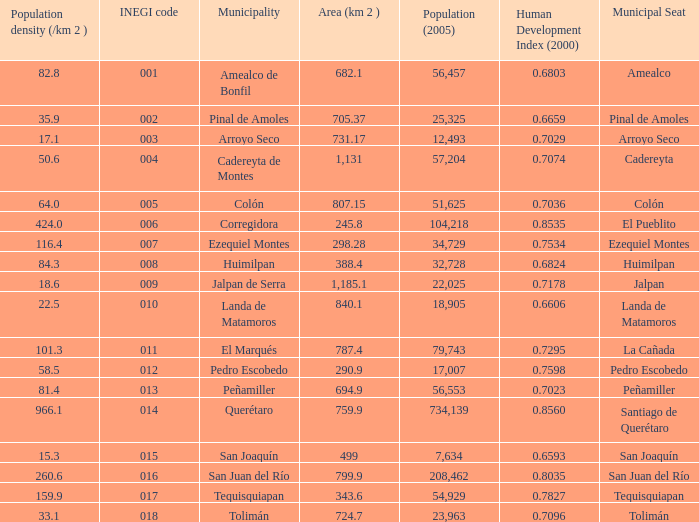Which Area (km 2 )has a Population (2005) of 57,204, and a Human Development Index (2000) smaller than 0.7074? 0.0. 